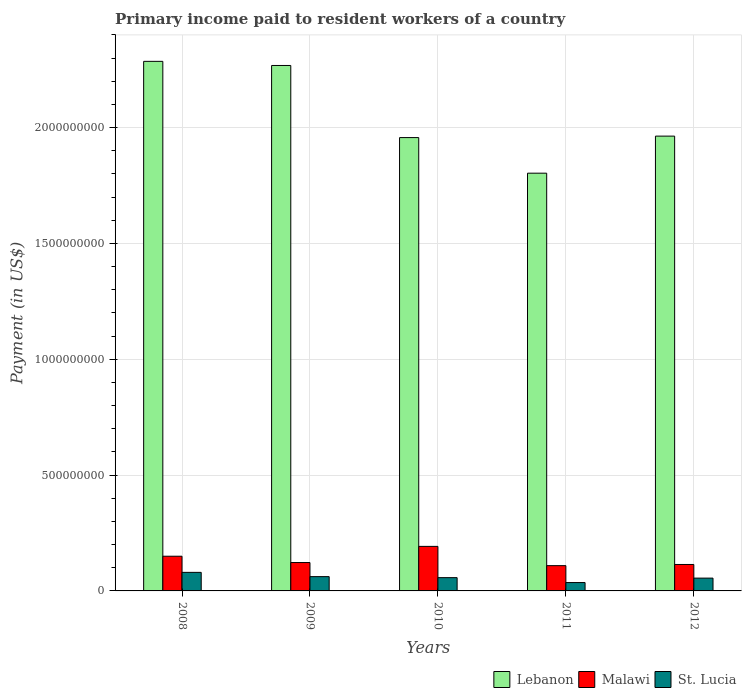How many different coloured bars are there?
Ensure brevity in your answer.  3. How many bars are there on the 2nd tick from the left?
Give a very brief answer. 3. How many bars are there on the 2nd tick from the right?
Keep it short and to the point. 3. In how many cases, is the number of bars for a given year not equal to the number of legend labels?
Provide a succinct answer. 0. What is the amount paid to workers in Lebanon in 2010?
Make the answer very short. 1.96e+09. Across all years, what is the maximum amount paid to workers in Malawi?
Your response must be concise. 1.92e+08. Across all years, what is the minimum amount paid to workers in Malawi?
Offer a terse response. 1.09e+08. In which year was the amount paid to workers in Malawi minimum?
Offer a terse response. 2011. What is the total amount paid to workers in Malawi in the graph?
Make the answer very short. 6.88e+08. What is the difference between the amount paid to workers in Lebanon in 2010 and that in 2011?
Make the answer very short. 1.54e+08. What is the difference between the amount paid to workers in Malawi in 2008 and the amount paid to workers in Lebanon in 2009?
Your response must be concise. -2.12e+09. What is the average amount paid to workers in Malawi per year?
Your answer should be compact. 1.38e+08. In the year 2012, what is the difference between the amount paid to workers in Malawi and amount paid to workers in Lebanon?
Your answer should be very brief. -1.85e+09. In how many years, is the amount paid to workers in Lebanon greater than 500000000 US$?
Your answer should be very brief. 5. What is the ratio of the amount paid to workers in St. Lucia in 2009 to that in 2010?
Your response must be concise. 1.08. Is the difference between the amount paid to workers in Malawi in 2009 and 2011 greater than the difference between the amount paid to workers in Lebanon in 2009 and 2011?
Keep it short and to the point. No. What is the difference between the highest and the second highest amount paid to workers in Lebanon?
Offer a terse response. 1.78e+07. What is the difference between the highest and the lowest amount paid to workers in Malawi?
Offer a very short reply. 8.31e+07. In how many years, is the amount paid to workers in Lebanon greater than the average amount paid to workers in Lebanon taken over all years?
Your answer should be compact. 2. Is the sum of the amount paid to workers in St. Lucia in 2008 and 2009 greater than the maximum amount paid to workers in Malawi across all years?
Make the answer very short. No. What does the 1st bar from the left in 2009 represents?
Your answer should be very brief. Lebanon. What does the 1st bar from the right in 2010 represents?
Keep it short and to the point. St. Lucia. Is it the case that in every year, the sum of the amount paid to workers in Malawi and amount paid to workers in Lebanon is greater than the amount paid to workers in St. Lucia?
Make the answer very short. Yes. How many bars are there?
Offer a terse response. 15. Are all the bars in the graph horizontal?
Provide a succinct answer. No. How many years are there in the graph?
Keep it short and to the point. 5. Are the values on the major ticks of Y-axis written in scientific E-notation?
Offer a terse response. No. What is the title of the graph?
Provide a succinct answer. Primary income paid to resident workers of a country. Does "New Zealand" appear as one of the legend labels in the graph?
Ensure brevity in your answer.  No. What is the label or title of the X-axis?
Offer a terse response. Years. What is the label or title of the Y-axis?
Make the answer very short. Payment (in US$). What is the Payment (in US$) in Lebanon in 2008?
Offer a very short reply. 2.29e+09. What is the Payment (in US$) of Malawi in 2008?
Your answer should be compact. 1.50e+08. What is the Payment (in US$) in St. Lucia in 2008?
Make the answer very short. 8.01e+07. What is the Payment (in US$) in Lebanon in 2009?
Offer a very short reply. 2.27e+09. What is the Payment (in US$) in Malawi in 2009?
Your answer should be very brief. 1.23e+08. What is the Payment (in US$) of St. Lucia in 2009?
Your answer should be compact. 6.17e+07. What is the Payment (in US$) of Lebanon in 2010?
Offer a terse response. 1.96e+09. What is the Payment (in US$) in Malawi in 2010?
Offer a very short reply. 1.92e+08. What is the Payment (in US$) of St. Lucia in 2010?
Keep it short and to the point. 5.73e+07. What is the Payment (in US$) of Lebanon in 2011?
Give a very brief answer. 1.80e+09. What is the Payment (in US$) of Malawi in 2011?
Give a very brief answer. 1.09e+08. What is the Payment (in US$) in St. Lucia in 2011?
Ensure brevity in your answer.  3.61e+07. What is the Payment (in US$) in Lebanon in 2012?
Your answer should be compact. 1.96e+09. What is the Payment (in US$) of Malawi in 2012?
Keep it short and to the point. 1.14e+08. What is the Payment (in US$) in St. Lucia in 2012?
Ensure brevity in your answer.  5.53e+07. Across all years, what is the maximum Payment (in US$) of Lebanon?
Your answer should be compact. 2.29e+09. Across all years, what is the maximum Payment (in US$) of Malawi?
Give a very brief answer. 1.92e+08. Across all years, what is the maximum Payment (in US$) in St. Lucia?
Your answer should be compact. 8.01e+07. Across all years, what is the minimum Payment (in US$) of Lebanon?
Make the answer very short. 1.80e+09. Across all years, what is the minimum Payment (in US$) of Malawi?
Your response must be concise. 1.09e+08. Across all years, what is the minimum Payment (in US$) of St. Lucia?
Your response must be concise. 3.61e+07. What is the total Payment (in US$) of Lebanon in the graph?
Provide a short and direct response. 1.03e+1. What is the total Payment (in US$) of Malawi in the graph?
Your response must be concise. 6.88e+08. What is the total Payment (in US$) of St. Lucia in the graph?
Offer a terse response. 2.90e+08. What is the difference between the Payment (in US$) of Lebanon in 2008 and that in 2009?
Make the answer very short. 1.78e+07. What is the difference between the Payment (in US$) in Malawi in 2008 and that in 2009?
Your answer should be very brief. 2.73e+07. What is the difference between the Payment (in US$) of St. Lucia in 2008 and that in 2009?
Offer a terse response. 1.84e+07. What is the difference between the Payment (in US$) in Lebanon in 2008 and that in 2010?
Provide a short and direct response. 3.29e+08. What is the difference between the Payment (in US$) in Malawi in 2008 and that in 2010?
Offer a very short reply. -4.25e+07. What is the difference between the Payment (in US$) of St. Lucia in 2008 and that in 2010?
Give a very brief answer. 2.28e+07. What is the difference between the Payment (in US$) in Lebanon in 2008 and that in 2011?
Your answer should be compact. 4.83e+08. What is the difference between the Payment (in US$) of Malawi in 2008 and that in 2011?
Ensure brevity in your answer.  4.07e+07. What is the difference between the Payment (in US$) in St. Lucia in 2008 and that in 2011?
Offer a very short reply. 4.40e+07. What is the difference between the Payment (in US$) in Lebanon in 2008 and that in 2012?
Provide a short and direct response. 3.23e+08. What is the difference between the Payment (in US$) of Malawi in 2008 and that in 2012?
Your answer should be compact. 3.56e+07. What is the difference between the Payment (in US$) of St. Lucia in 2008 and that in 2012?
Give a very brief answer. 2.48e+07. What is the difference between the Payment (in US$) of Lebanon in 2009 and that in 2010?
Provide a short and direct response. 3.11e+08. What is the difference between the Payment (in US$) of Malawi in 2009 and that in 2010?
Make the answer very short. -6.97e+07. What is the difference between the Payment (in US$) in St. Lucia in 2009 and that in 2010?
Your answer should be compact. 4.39e+06. What is the difference between the Payment (in US$) in Lebanon in 2009 and that in 2011?
Your answer should be compact. 4.65e+08. What is the difference between the Payment (in US$) in Malawi in 2009 and that in 2011?
Make the answer very short. 1.34e+07. What is the difference between the Payment (in US$) in St. Lucia in 2009 and that in 2011?
Ensure brevity in your answer.  2.56e+07. What is the difference between the Payment (in US$) of Lebanon in 2009 and that in 2012?
Give a very brief answer. 3.05e+08. What is the difference between the Payment (in US$) in Malawi in 2009 and that in 2012?
Your answer should be very brief. 8.36e+06. What is the difference between the Payment (in US$) of St. Lucia in 2009 and that in 2012?
Make the answer very short. 6.37e+06. What is the difference between the Payment (in US$) in Lebanon in 2010 and that in 2011?
Offer a terse response. 1.54e+08. What is the difference between the Payment (in US$) of Malawi in 2010 and that in 2011?
Give a very brief answer. 8.31e+07. What is the difference between the Payment (in US$) of St. Lucia in 2010 and that in 2011?
Offer a terse response. 2.12e+07. What is the difference between the Payment (in US$) in Lebanon in 2010 and that in 2012?
Ensure brevity in your answer.  -6.35e+06. What is the difference between the Payment (in US$) of Malawi in 2010 and that in 2012?
Provide a succinct answer. 7.81e+07. What is the difference between the Payment (in US$) of St. Lucia in 2010 and that in 2012?
Your response must be concise. 1.98e+06. What is the difference between the Payment (in US$) in Lebanon in 2011 and that in 2012?
Make the answer very short. -1.60e+08. What is the difference between the Payment (in US$) of Malawi in 2011 and that in 2012?
Ensure brevity in your answer.  -5.05e+06. What is the difference between the Payment (in US$) of St. Lucia in 2011 and that in 2012?
Provide a short and direct response. -1.92e+07. What is the difference between the Payment (in US$) of Lebanon in 2008 and the Payment (in US$) of Malawi in 2009?
Your response must be concise. 2.16e+09. What is the difference between the Payment (in US$) of Lebanon in 2008 and the Payment (in US$) of St. Lucia in 2009?
Provide a short and direct response. 2.22e+09. What is the difference between the Payment (in US$) in Malawi in 2008 and the Payment (in US$) in St. Lucia in 2009?
Your answer should be compact. 8.81e+07. What is the difference between the Payment (in US$) in Lebanon in 2008 and the Payment (in US$) in Malawi in 2010?
Provide a succinct answer. 2.09e+09. What is the difference between the Payment (in US$) of Lebanon in 2008 and the Payment (in US$) of St. Lucia in 2010?
Provide a short and direct response. 2.23e+09. What is the difference between the Payment (in US$) of Malawi in 2008 and the Payment (in US$) of St. Lucia in 2010?
Your answer should be compact. 9.25e+07. What is the difference between the Payment (in US$) in Lebanon in 2008 and the Payment (in US$) in Malawi in 2011?
Your answer should be very brief. 2.18e+09. What is the difference between the Payment (in US$) in Lebanon in 2008 and the Payment (in US$) in St. Lucia in 2011?
Your answer should be very brief. 2.25e+09. What is the difference between the Payment (in US$) in Malawi in 2008 and the Payment (in US$) in St. Lucia in 2011?
Offer a terse response. 1.14e+08. What is the difference between the Payment (in US$) of Lebanon in 2008 and the Payment (in US$) of Malawi in 2012?
Your answer should be very brief. 2.17e+09. What is the difference between the Payment (in US$) in Lebanon in 2008 and the Payment (in US$) in St. Lucia in 2012?
Your response must be concise. 2.23e+09. What is the difference between the Payment (in US$) in Malawi in 2008 and the Payment (in US$) in St. Lucia in 2012?
Keep it short and to the point. 9.45e+07. What is the difference between the Payment (in US$) in Lebanon in 2009 and the Payment (in US$) in Malawi in 2010?
Your answer should be compact. 2.08e+09. What is the difference between the Payment (in US$) in Lebanon in 2009 and the Payment (in US$) in St. Lucia in 2010?
Provide a succinct answer. 2.21e+09. What is the difference between the Payment (in US$) in Malawi in 2009 and the Payment (in US$) in St. Lucia in 2010?
Your answer should be compact. 6.53e+07. What is the difference between the Payment (in US$) of Lebanon in 2009 and the Payment (in US$) of Malawi in 2011?
Provide a succinct answer. 2.16e+09. What is the difference between the Payment (in US$) of Lebanon in 2009 and the Payment (in US$) of St. Lucia in 2011?
Offer a very short reply. 2.23e+09. What is the difference between the Payment (in US$) of Malawi in 2009 and the Payment (in US$) of St. Lucia in 2011?
Provide a succinct answer. 8.64e+07. What is the difference between the Payment (in US$) in Lebanon in 2009 and the Payment (in US$) in Malawi in 2012?
Your response must be concise. 2.15e+09. What is the difference between the Payment (in US$) in Lebanon in 2009 and the Payment (in US$) in St. Lucia in 2012?
Your answer should be very brief. 2.21e+09. What is the difference between the Payment (in US$) in Malawi in 2009 and the Payment (in US$) in St. Lucia in 2012?
Offer a terse response. 6.72e+07. What is the difference between the Payment (in US$) of Lebanon in 2010 and the Payment (in US$) of Malawi in 2011?
Make the answer very short. 1.85e+09. What is the difference between the Payment (in US$) in Lebanon in 2010 and the Payment (in US$) in St. Lucia in 2011?
Provide a succinct answer. 1.92e+09. What is the difference between the Payment (in US$) in Malawi in 2010 and the Payment (in US$) in St. Lucia in 2011?
Your answer should be compact. 1.56e+08. What is the difference between the Payment (in US$) of Lebanon in 2010 and the Payment (in US$) of Malawi in 2012?
Offer a terse response. 1.84e+09. What is the difference between the Payment (in US$) in Lebanon in 2010 and the Payment (in US$) in St. Lucia in 2012?
Your answer should be compact. 1.90e+09. What is the difference between the Payment (in US$) of Malawi in 2010 and the Payment (in US$) of St. Lucia in 2012?
Give a very brief answer. 1.37e+08. What is the difference between the Payment (in US$) in Lebanon in 2011 and the Payment (in US$) in Malawi in 2012?
Offer a terse response. 1.69e+09. What is the difference between the Payment (in US$) of Lebanon in 2011 and the Payment (in US$) of St. Lucia in 2012?
Give a very brief answer. 1.75e+09. What is the difference between the Payment (in US$) in Malawi in 2011 and the Payment (in US$) in St. Lucia in 2012?
Offer a very short reply. 5.38e+07. What is the average Payment (in US$) of Lebanon per year?
Offer a very short reply. 2.06e+09. What is the average Payment (in US$) in Malawi per year?
Make the answer very short. 1.38e+08. What is the average Payment (in US$) in St. Lucia per year?
Give a very brief answer. 5.81e+07. In the year 2008, what is the difference between the Payment (in US$) of Lebanon and Payment (in US$) of Malawi?
Provide a short and direct response. 2.14e+09. In the year 2008, what is the difference between the Payment (in US$) in Lebanon and Payment (in US$) in St. Lucia?
Give a very brief answer. 2.21e+09. In the year 2008, what is the difference between the Payment (in US$) of Malawi and Payment (in US$) of St. Lucia?
Make the answer very short. 6.97e+07. In the year 2009, what is the difference between the Payment (in US$) in Lebanon and Payment (in US$) in Malawi?
Your response must be concise. 2.15e+09. In the year 2009, what is the difference between the Payment (in US$) in Lebanon and Payment (in US$) in St. Lucia?
Provide a short and direct response. 2.21e+09. In the year 2009, what is the difference between the Payment (in US$) of Malawi and Payment (in US$) of St. Lucia?
Provide a succinct answer. 6.09e+07. In the year 2010, what is the difference between the Payment (in US$) in Lebanon and Payment (in US$) in Malawi?
Give a very brief answer. 1.76e+09. In the year 2010, what is the difference between the Payment (in US$) of Lebanon and Payment (in US$) of St. Lucia?
Give a very brief answer. 1.90e+09. In the year 2010, what is the difference between the Payment (in US$) in Malawi and Payment (in US$) in St. Lucia?
Offer a very short reply. 1.35e+08. In the year 2011, what is the difference between the Payment (in US$) in Lebanon and Payment (in US$) in Malawi?
Offer a terse response. 1.69e+09. In the year 2011, what is the difference between the Payment (in US$) of Lebanon and Payment (in US$) of St. Lucia?
Ensure brevity in your answer.  1.77e+09. In the year 2011, what is the difference between the Payment (in US$) in Malawi and Payment (in US$) in St. Lucia?
Provide a succinct answer. 7.30e+07. In the year 2012, what is the difference between the Payment (in US$) of Lebanon and Payment (in US$) of Malawi?
Offer a terse response. 1.85e+09. In the year 2012, what is the difference between the Payment (in US$) in Lebanon and Payment (in US$) in St. Lucia?
Give a very brief answer. 1.91e+09. In the year 2012, what is the difference between the Payment (in US$) in Malawi and Payment (in US$) in St. Lucia?
Your answer should be very brief. 5.89e+07. What is the ratio of the Payment (in US$) in Lebanon in 2008 to that in 2009?
Keep it short and to the point. 1.01. What is the ratio of the Payment (in US$) in Malawi in 2008 to that in 2009?
Offer a very short reply. 1.22. What is the ratio of the Payment (in US$) of St. Lucia in 2008 to that in 2009?
Keep it short and to the point. 1.3. What is the ratio of the Payment (in US$) in Lebanon in 2008 to that in 2010?
Your answer should be compact. 1.17. What is the ratio of the Payment (in US$) of Malawi in 2008 to that in 2010?
Your answer should be very brief. 0.78. What is the ratio of the Payment (in US$) of St. Lucia in 2008 to that in 2010?
Offer a very short reply. 1.4. What is the ratio of the Payment (in US$) in Lebanon in 2008 to that in 2011?
Provide a short and direct response. 1.27. What is the ratio of the Payment (in US$) in Malawi in 2008 to that in 2011?
Keep it short and to the point. 1.37. What is the ratio of the Payment (in US$) in St. Lucia in 2008 to that in 2011?
Provide a succinct answer. 2.22. What is the ratio of the Payment (in US$) of Lebanon in 2008 to that in 2012?
Ensure brevity in your answer.  1.16. What is the ratio of the Payment (in US$) of Malawi in 2008 to that in 2012?
Give a very brief answer. 1.31. What is the ratio of the Payment (in US$) in St. Lucia in 2008 to that in 2012?
Make the answer very short. 1.45. What is the ratio of the Payment (in US$) in Lebanon in 2009 to that in 2010?
Give a very brief answer. 1.16. What is the ratio of the Payment (in US$) in Malawi in 2009 to that in 2010?
Offer a terse response. 0.64. What is the ratio of the Payment (in US$) in St. Lucia in 2009 to that in 2010?
Offer a very short reply. 1.08. What is the ratio of the Payment (in US$) of Lebanon in 2009 to that in 2011?
Provide a short and direct response. 1.26. What is the ratio of the Payment (in US$) in Malawi in 2009 to that in 2011?
Provide a short and direct response. 1.12. What is the ratio of the Payment (in US$) in St. Lucia in 2009 to that in 2011?
Provide a short and direct response. 1.71. What is the ratio of the Payment (in US$) in Lebanon in 2009 to that in 2012?
Make the answer very short. 1.16. What is the ratio of the Payment (in US$) in Malawi in 2009 to that in 2012?
Offer a very short reply. 1.07. What is the ratio of the Payment (in US$) of St. Lucia in 2009 to that in 2012?
Provide a succinct answer. 1.12. What is the ratio of the Payment (in US$) of Lebanon in 2010 to that in 2011?
Your answer should be compact. 1.09. What is the ratio of the Payment (in US$) of Malawi in 2010 to that in 2011?
Your response must be concise. 1.76. What is the ratio of the Payment (in US$) in St. Lucia in 2010 to that in 2011?
Provide a short and direct response. 1.59. What is the ratio of the Payment (in US$) of Lebanon in 2010 to that in 2012?
Give a very brief answer. 1. What is the ratio of the Payment (in US$) in Malawi in 2010 to that in 2012?
Make the answer very short. 1.68. What is the ratio of the Payment (in US$) of St. Lucia in 2010 to that in 2012?
Your answer should be very brief. 1.04. What is the ratio of the Payment (in US$) of Lebanon in 2011 to that in 2012?
Make the answer very short. 0.92. What is the ratio of the Payment (in US$) of Malawi in 2011 to that in 2012?
Provide a succinct answer. 0.96. What is the ratio of the Payment (in US$) of St. Lucia in 2011 to that in 2012?
Provide a short and direct response. 0.65. What is the difference between the highest and the second highest Payment (in US$) in Lebanon?
Your response must be concise. 1.78e+07. What is the difference between the highest and the second highest Payment (in US$) of Malawi?
Ensure brevity in your answer.  4.25e+07. What is the difference between the highest and the second highest Payment (in US$) of St. Lucia?
Provide a succinct answer. 1.84e+07. What is the difference between the highest and the lowest Payment (in US$) in Lebanon?
Offer a very short reply. 4.83e+08. What is the difference between the highest and the lowest Payment (in US$) of Malawi?
Provide a short and direct response. 8.31e+07. What is the difference between the highest and the lowest Payment (in US$) of St. Lucia?
Your answer should be compact. 4.40e+07. 